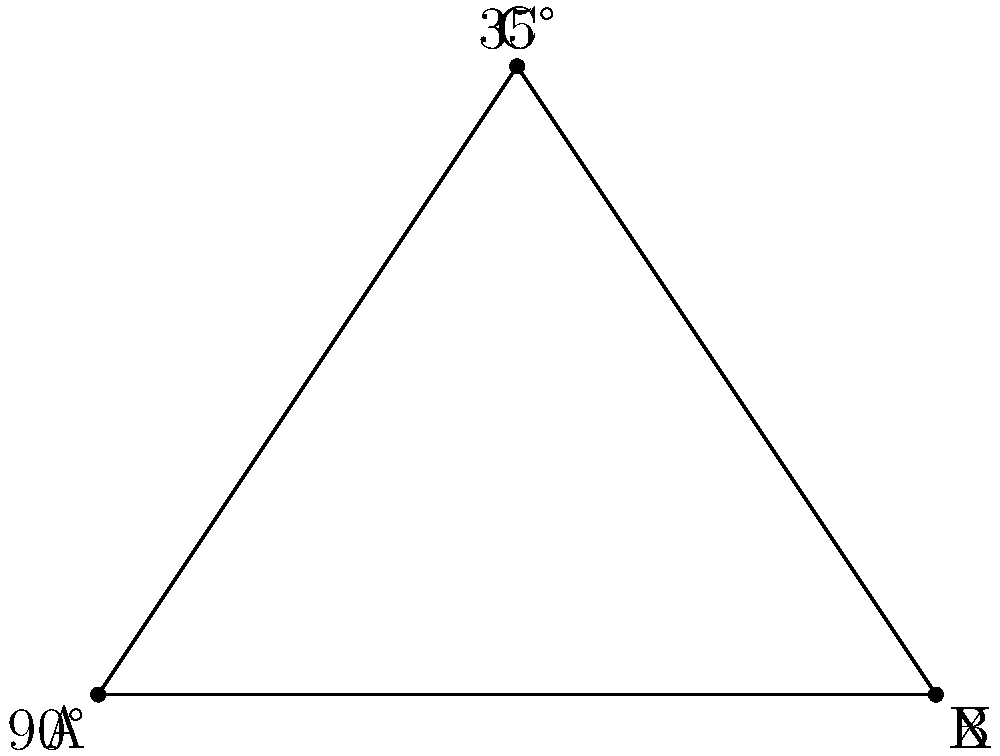You're arranging your vintage X-Men comics on a shelf, and two comic book spines intersect to form a right angle at point A. If the angle at point C is 35°, what is the measure of angle X at point B? To solve this problem, let's follow these steps:

1. Recall that the sum of angles in a triangle is always 180°.

2. We're given two angles in the triangle:
   - The right angle at A, which is 90°
   - The angle at C, which is 35°

3. Let's call the angle we're looking for at B as x°.

4. We can set up an equation based on the fact that the sum of angles in a triangle is 180°:
   $90° + 35° + x° = 180°$

5. Simplify the left side of the equation:
   $125° + x° = 180°$

6. Subtract 125° from both sides:
   $x° = 180° - 125°$

7. Solve for x:
   $x° = 55°$

Therefore, the measure of angle X at point B is 55°.
Answer: 55° 